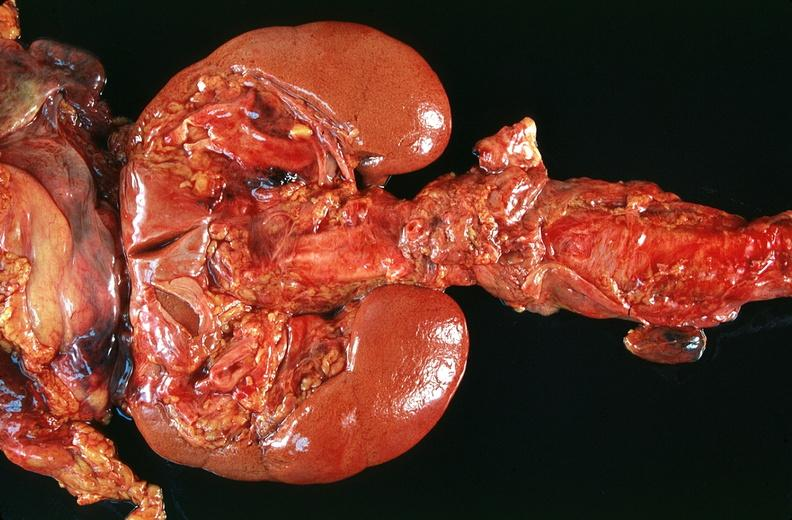what does this image show?
Answer the question using a single word or phrase. Horseshoe kidney in an adult 